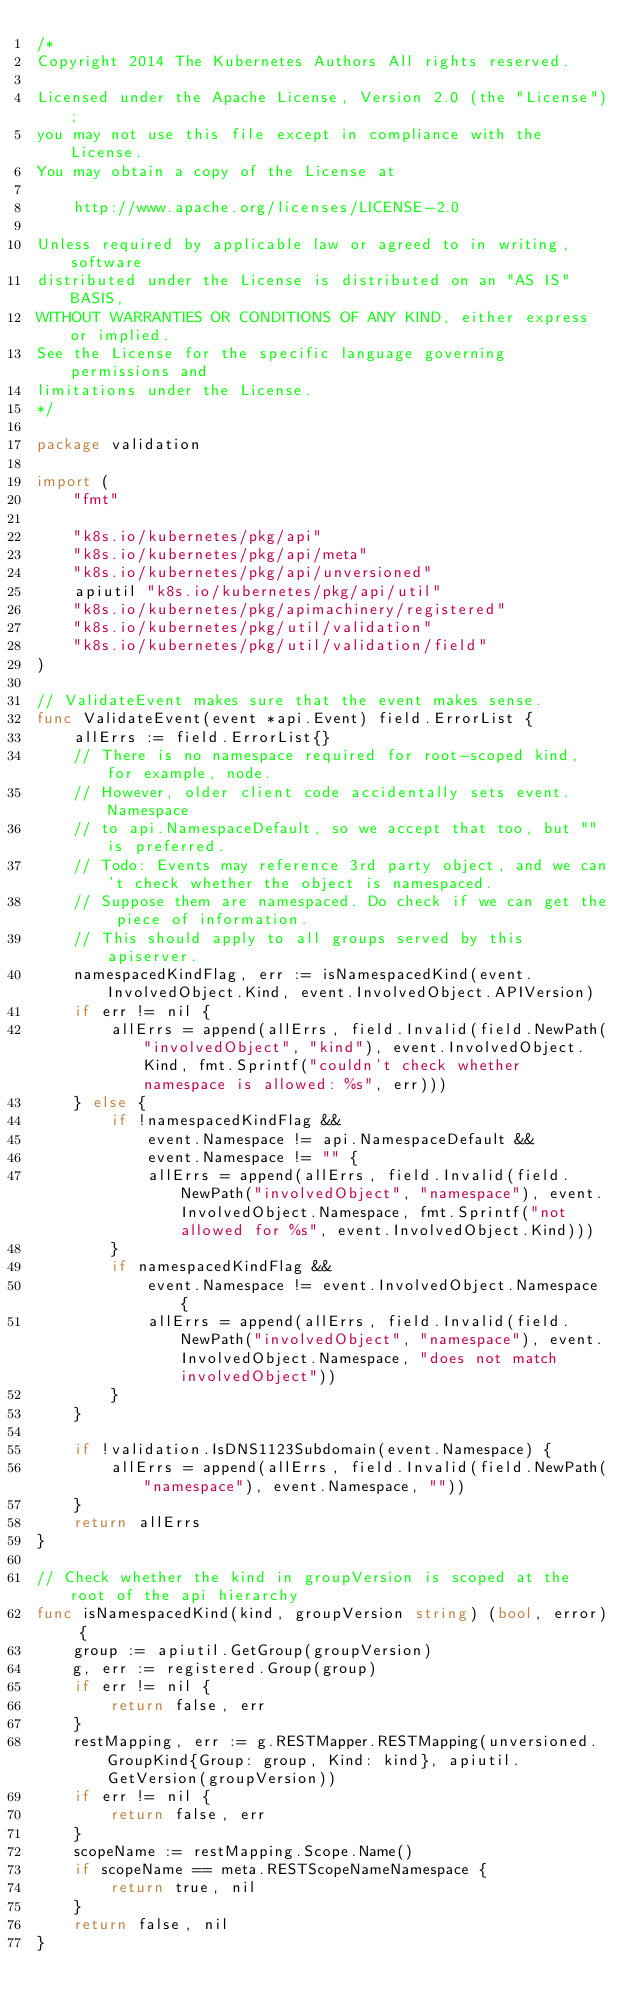Convert code to text. <code><loc_0><loc_0><loc_500><loc_500><_Go_>/*
Copyright 2014 The Kubernetes Authors All rights reserved.

Licensed under the Apache License, Version 2.0 (the "License");
you may not use this file except in compliance with the License.
You may obtain a copy of the License at

    http://www.apache.org/licenses/LICENSE-2.0

Unless required by applicable law or agreed to in writing, software
distributed under the License is distributed on an "AS IS" BASIS,
WITHOUT WARRANTIES OR CONDITIONS OF ANY KIND, either express or implied.
See the License for the specific language governing permissions and
limitations under the License.
*/

package validation

import (
	"fmt"

	"k8s.io/kubernetes/pkg/api"
	"k8s.io/kubernetes/pkg/api/meta"
	"k8s.io/kubernetes/pkg/api/unversioned"
	apiutil "k8s.io/kubernetes/pkg/api/util"
	"k8s.io/kubernetes/pkg/apimachinery/registered"
	"k8s.io/kubernetes/pkg/util/validation"
	"k8s.io/kubernetes/pkg/util/validation/field"
)

// ValidateEvent makes sure that the event makes sense.
func ValidateEvent(event *api.Event) field.ErrorList {
	allErrs := field.ErrorList{}
	// There is no namespace required for root-scoped kind, for example, node.
	// However, older client code accidentally sets event.Namespace
	// to api.NamespaceDefault, so we accept that too, but "" is preferred.
	// Todo: Events may reference 3rd party object, and we can't check whether the object is namespaced.
	// Suppose them are namespaced. Do check if we can get the piece of information.
	// This should apply to all groups served by this apiserver.
	namespacedKindFlag, err := isNamespacedKind(event.InvolvedObject.Kind, event.InvolvedObject.APIVersion)
	if err != nil {
		allErrs = append(allErrs, field.Invalid(field.NewPath("involvedObject", "kind"), event.InvolvedObject.Kind, fmt.Sprintf("couldn't check whether namespace is allowed: %s", err)))
	} else {
		if !namespacedKindFlag &&
			event.Namespace != api.NamespaceDefault &&
			event.Namespace != "" {
			allErrs = append(allErrs, field.Invalid(field.NewPath("involvedObject", "namespace"), event.InvolvedObject.Namespace, fmt.Sprintf("not allowed for %s", event.InvolvedObject.Kind)))
		}
		if namespacedKindFlag &&
			event.Namespace != event.InvolvedObject.Namespace {
			allErrs = append(allErrs, field.Invalid(field.NewPath("involvedObject", "namespace"), event.InvolvedObject.Namespace, "does not match involvedObject"))
		}
	}

	if !validation.IsDNS1123Subdomain(event.Namespace) {
		allErrs = append(allErrs, field.Invalid(field.NewPath("namespace"), event.Namespace, ""))
	}
	return allErrs
}

// Check whether the kind in groupVersion is scoped at the root of the api hierarchy
func isNamespacedKind(kind, groupVersion string) (bool, error) {
	group := apiutil.GetGroup(groupVersion)
	g, err := registered.Group(group)
	if err != nil {
		return false, err
	}
	restMapping, err := g.RESTMapper.RESTMapping(unversioned.GroupKind{Group: group, Kind: kind}, apiutil.GetVersion(groupVersion))
	if err != nil {
		return false, err
	}
	scopeName := restMapping.Scope.Name()
	if scopeName == meta.RESTScopeNameNamespace {
		return true, nil
	}
	return false, nil
}
</code> 